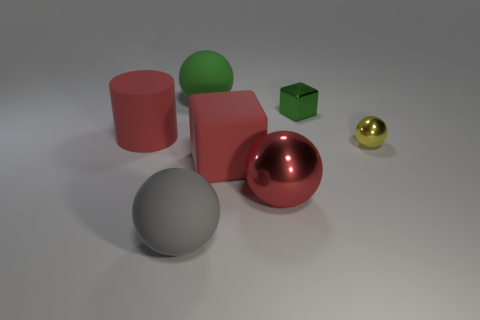Add 3 gray rubber things. How many objects exist? 10 Subtract all spheres. How many objects are left? 3 Add 1 big red spheres. How many big red spheres exist? 2 Subtract 0 gray cylinders. How many objects are left? 7 Subtract all green cubes. Subtract all red balls. How many objects are left? 5 Add 1 tiny metallic cubes. How many tiny metallic cubes are left? 2 